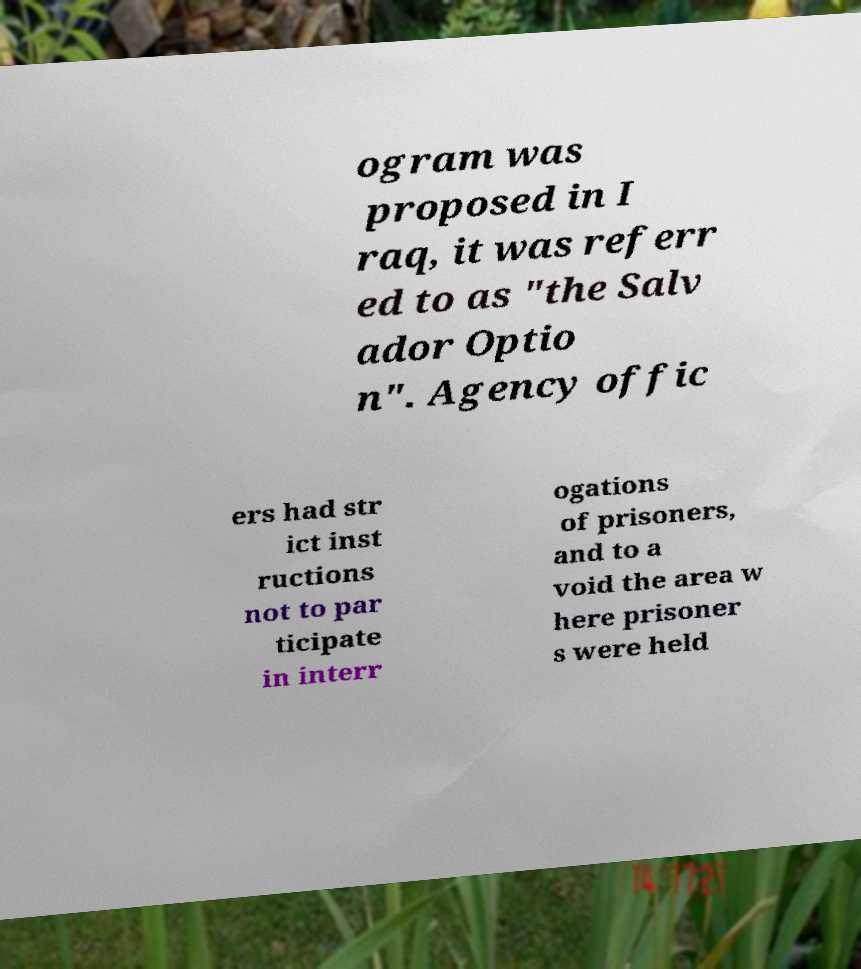Can you read and provide the text displayed in the image?This photo seems to have some interesting text. Can you extract and type it out for me? ogram was proposed in I raq, it was referr ed to as "the Salv ador Optio n". Agency offic ers had str ict inst ructions not to par ticipate in interr ogations of prisoners, and to a void the area w here prisoner s were held 